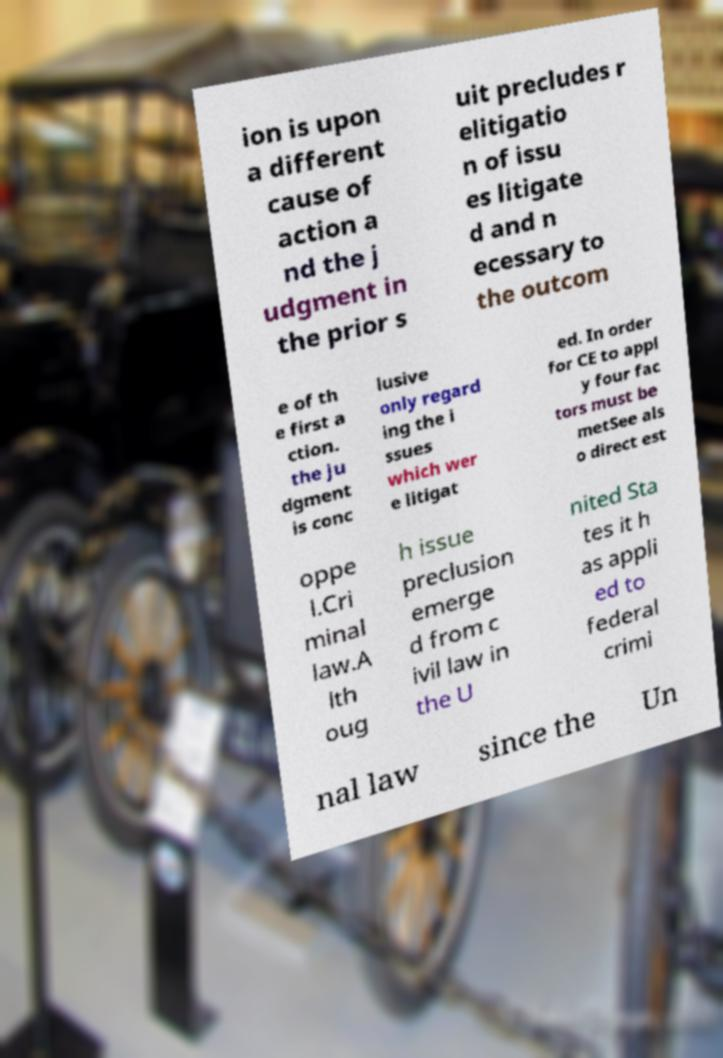Can you accurately transcribe the text from the provided image for me? ion is upon a different cause of action a nd the j udgment in the prior s uit precludes r elitigatio n of issu es litigate d and n ecessary to the outcom e of th e first a ction. the ju dgment is conc lusive only regard ing the i ssues which wer e litigat ed. In order for CE to appl y four fac tors must be metSee als o direct est oppe l.Cri minal law.A lth oug h issue preclusion emerge d from c ivil law in the U nited Sta tes it h as appli ed to federal crimi nal law since the Un 